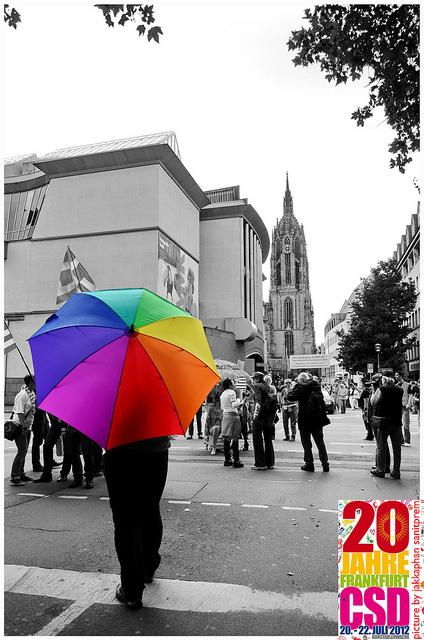What number can be seen?
Answer briefly. 20. Has this image been edited in a graphics program?
Write a very short answer. Yes. What is the colored Object?
Be succinct. Umbrella. 